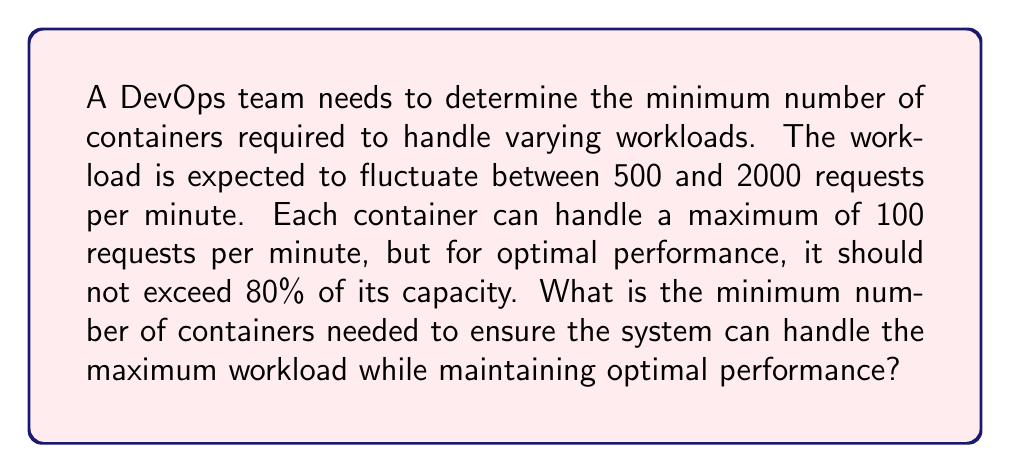Show me your answer to this math problem. Let's approach this step-by-step:

1. Calculate the effective capacity of each container:
   Maximum capacity = 100 requests/minute
   Optimal capacity = 80% of maximum = $100 \times 0.8 = 80$ requests/minute

2. Determine the number of containers needed for the maximum workload:
   Maximum workload = 2000 requests/minute
   Number of containers = $\frac{\text{Maximum workload}}{\text{Optimal capacity per container}}$
   
   $$ \text{Number of containers} = \frac{2000}{80} = 25 $$

3. Since we can't have a fractional number of containers, we need to round up to the nearest whole number:

   $$ \text{Minimum number of containers} = \lceil 25 \rceil = 25 $$

4. Verify that this number of containers can handle the maximum workload:
   Total capacity = $25 \times 80 = 2000$ requests/minute

5. Check that this solution satisfies the inequality:
   $$ 500 \leq \text{Workload} \leq 2000 \leq 25 \times 80 $$
   The inequality holds, confirming our solution.
Answer: 25 containers 